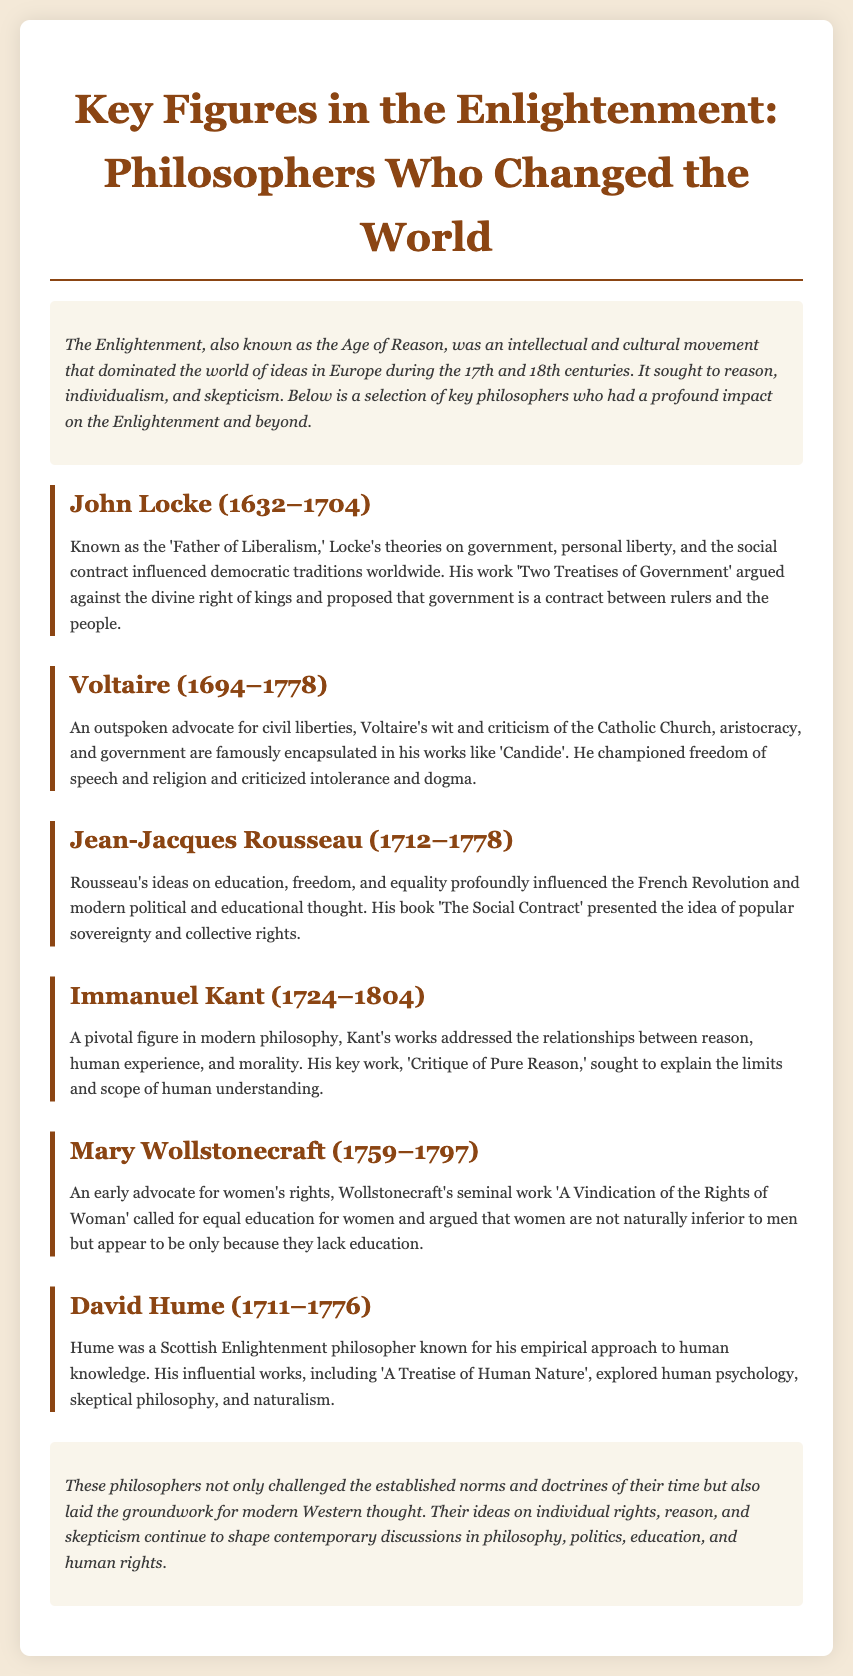What is the title of the document? The title of the document is provided in the header, which summarizes the focus of the content.
Answer: Key Figures in the Enlightenment: Philosophers Who Changed the World Who is known as the 'Father of Liberalism'? This title is specifically attributed to a philosopher discussed in the document, highlighting his influence on democratic traditions.
Answer: John Locke What year was Mary Wollstonecraft born? The document states the birth year of Mary Wollstonecraft, which is important for historical context.
Answer: 1759 Which philosopher criticized the Catholic Church? The document mentions a philosopher who was an advocate for civil liberties and criticized established religious institutions.
Answer: Voltaire What is the core idea presented in Rousseau's 'The Social Contract'? The document explains Rousseau's contributions to political thought, specifically focusing on a fundamental concept in governance.
Answer: Popular sovereignty In what year did Immanuel Kant pass away? The document provides the death year of Kant, which is relevant for understanding the timeline of Enlightenment thinkers.
Answer: 1804 Which work by John Locke argued against the divine right of kings? The document lists key works by philosophers and emphasizes Locke's criticism of monarchical power.
Answer: Two Treatises of Government Which philosophical approach is David Hume known for? The document highlights Hume's methodology in exploring human understanding and knowledge.
Answer: Empirical approach What major theme is common among the philosophers discussed in the document? The document discusses overarching themes related to the philosophers' contributions, such as rights and reason.
Answer: Individual rights 